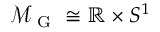Convert formula to latex. <formula><loc_0><loc_0><loc_500><loc_500>\mathcal { M } _ { G } \cong \mathbb { R } \times S ^ { 1 }</formula> 